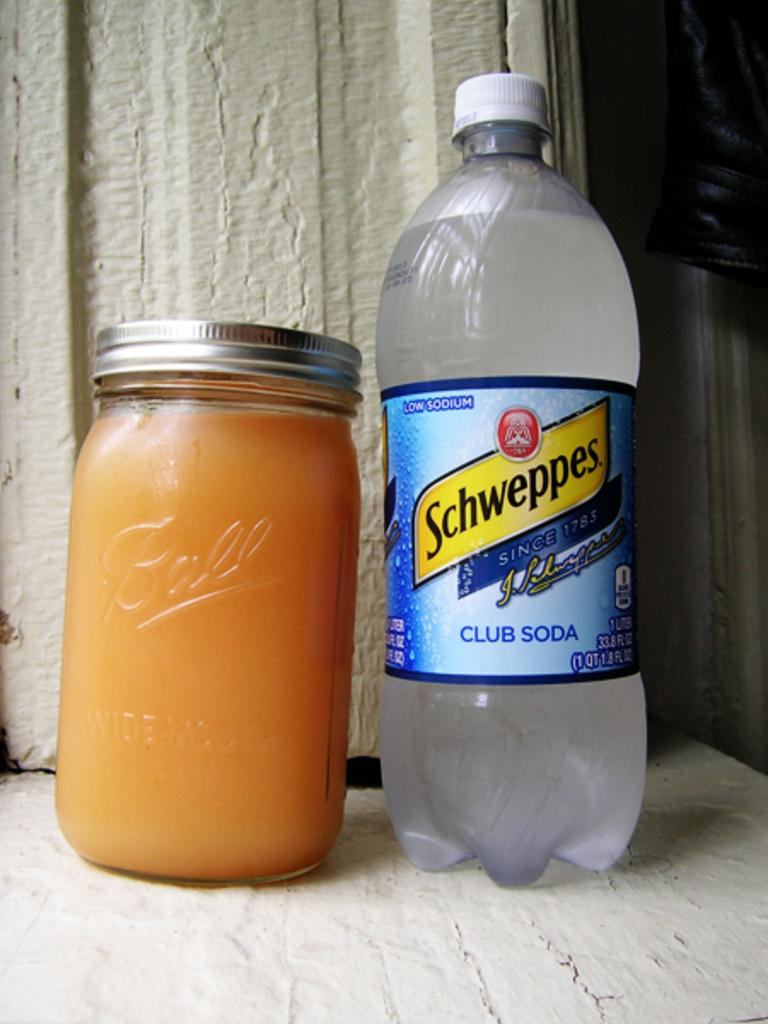<image>
Give a short and clear explanation of the subsequent image. A bottle of Schweppes Club Soda is sitting next to a full jar. 